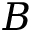<formula> <loc_0><loc_0><loc_500><loc_500>B</formula> 